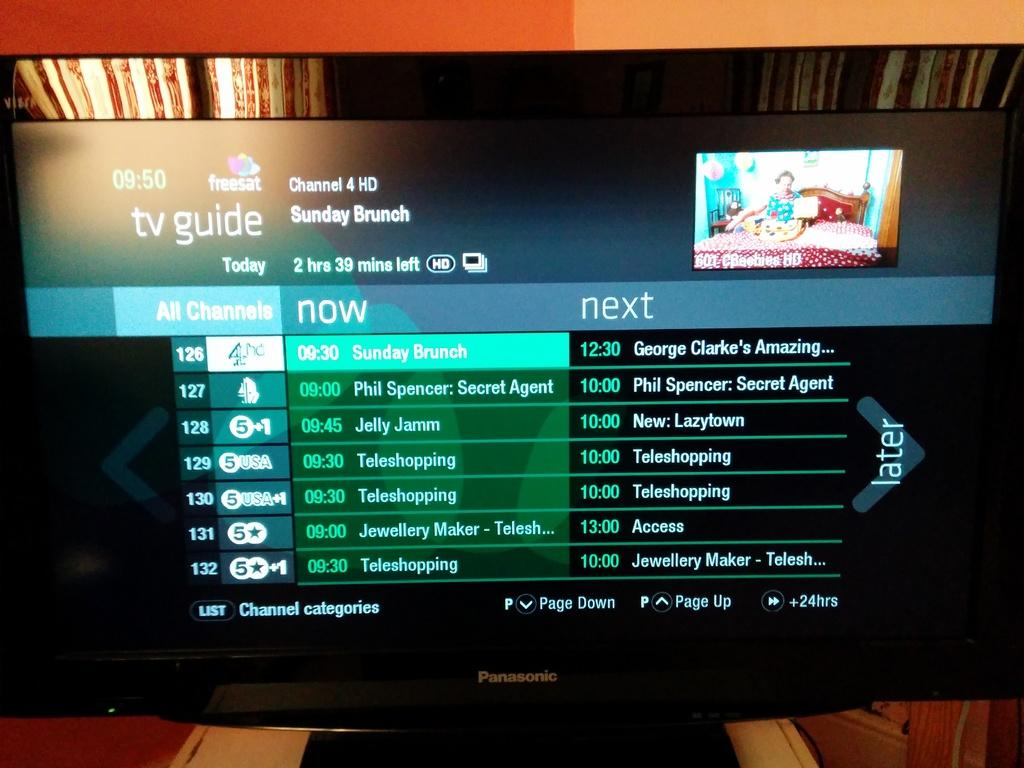<image>
Offer a succinct explanation of the picture presented. A Panasonic television set showing a tv guide display. 